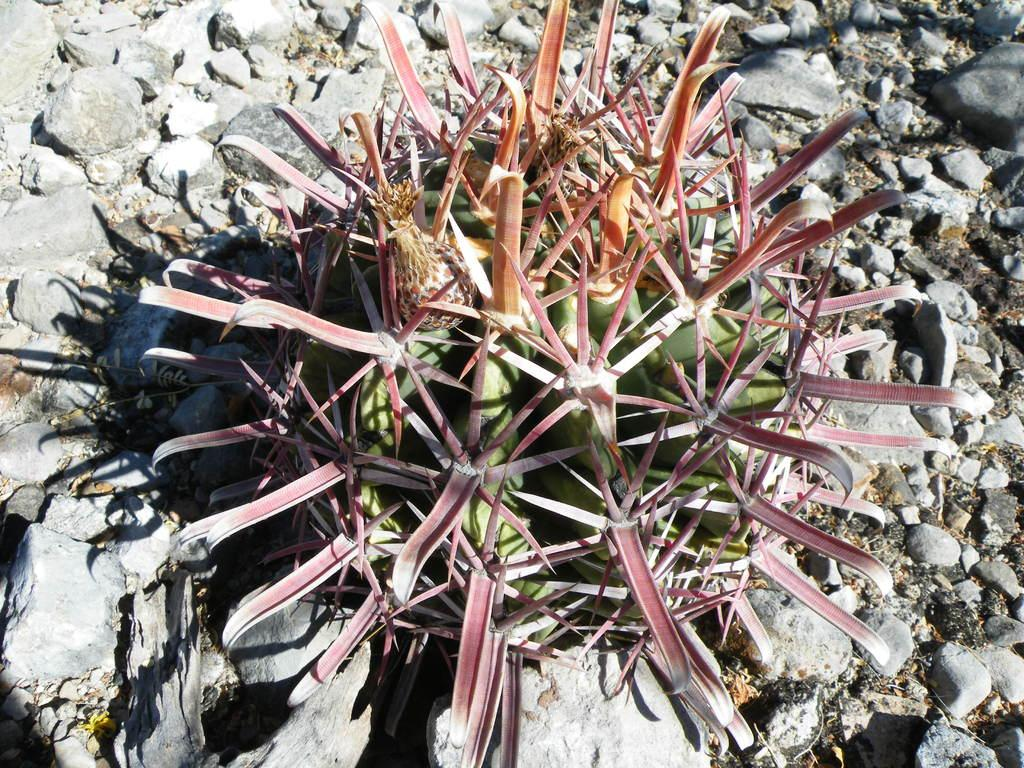What type of plant is in the image? There is a cactus plant in the image. Where is the cactus plant located? The cactus plant is on the land. What else can be seen on the cactus plant? There are rocks on the cactus plant. What advice does the cactus plant give to the snail in the image? There is no snail present in the image, so the cactus plant cannot give any advice to it. 